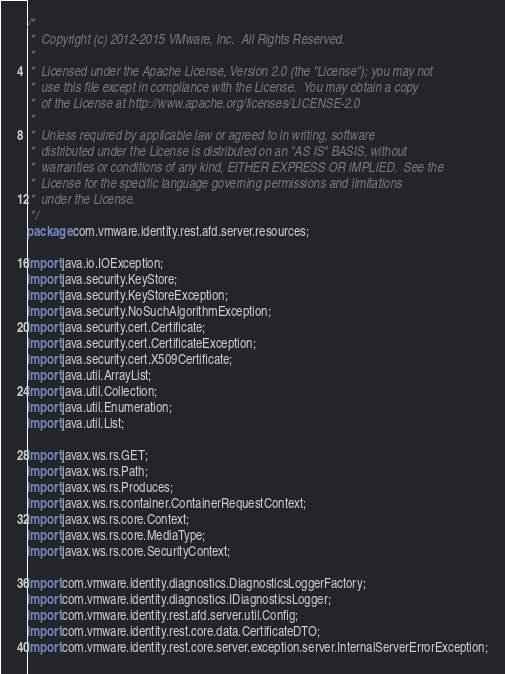<code> <loc_0><loc_0><loc_500><loc_500><_Java_>/*
 *  Copyright (c) 2012-2015 VMware, Inc.  All Rights Reserved.
 *
 *  Licensed under the Apache License, Version 2.0 (the "License"); you may not
 *  use this file except in compliance with the License.  You may obtain a copy
 *  of the License at http://www.apache.org/licenses/LICENSE-2.0
 *
 *  Unless required by applicable law or agreed to in writing, software
 *  distributed under the License is distributed on an "AS IS" BASIS, without
 *  warranties or conditions of any kind, EITHER EXPRESS OR IMPLIED.  See the
 *  License for the specific language governing permissions and limitations
 *  under the License.
 */
package com.vmware.identity.rest.afd.server.resources;

import java.io.IOException;
import java.security.KeyStore;
import java.security.KeyStoreException;
import java.security.NoSuchAlgorithmException;
import java.security.cert.Certificate;
import java.security.cert.CertificateException;
import java.security.cert.X509Certificate;
import java.util.ArrayList;
import java.util.Collection;
import java.util.Enumeration;
import java.util.List;

import javax.ws.rs.GET;
import javax.ws.rs.Path;
import javax.ws.rs.Produces;
import javax.ws.rs.container.ContainerRequestContext;
import javax.ws.rs.core.Context;
import javax.ws.rs.core.MediaType;
import javax.ws.rs.core.SecurityContext;

import com.vmware.identity.diagnostics.DiagnosticsLoggerFactory;
import com.vmware.identity.diagnostics.IDiagnosticsLogger;
import com.vmware.identity.rest.afd.server.util.Config;
import com.vmware.identity.rest.core.data.CertificateDTO;
import com.vmware.identity.rest.core.server.exception.server.InternalServerErrorException;</code> 